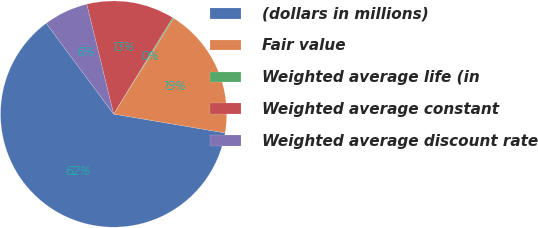<chart> <loc_0><loc_0><loc_500><loc_500><pie_chart><fcel>(dollars in millions)<fcel>Fair value<fcel>Weighted average life (in<fcel>Weighted average constant<fcel>Weighted average discount rate<nl><fcel>62.15%<fcel>18.76%<fcel>0.17%<fcel>12.56%<fcel>6.36%<nl></chart> 